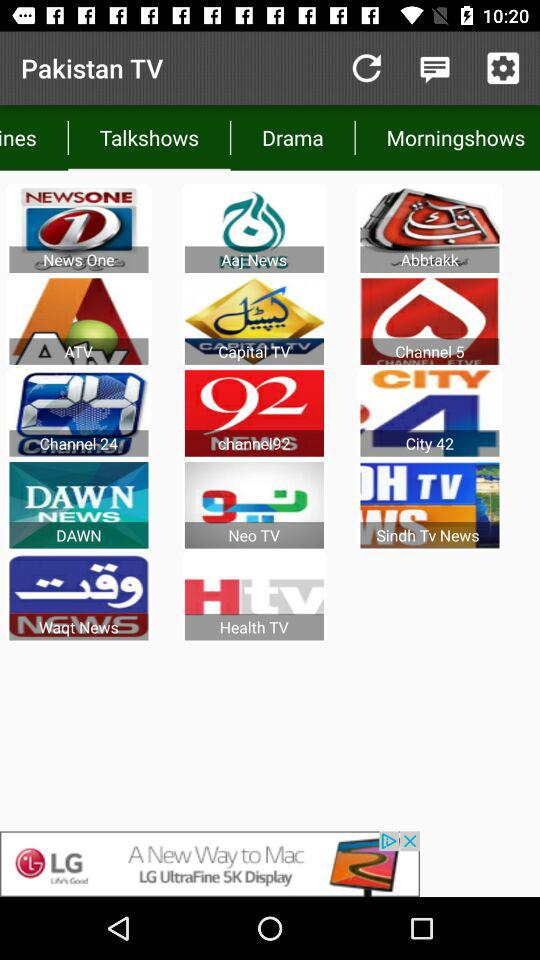Which tab is selected? The selected tab is "Talkshows". 